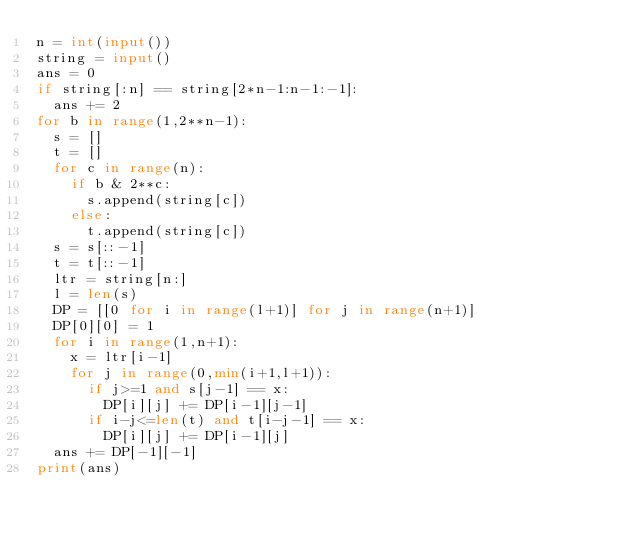<code> <loc_0><loc_0><loc_500><loc_500><_Python_>n = int(input())
string = input()
ans = 0
if string[:n] == string[2*n-1:n-1:-1]:
  ans += 2
for b in range(1,2**n-1):
  s = []
  t = []
  for c in range(n):
    if b & 2**c:
      s.append(string[c])
    else:
      t.append(string[c])
  s = s[::-1]
  t = t[::-1]
  ltr = string[n:]
  l = len(s)
  DP = [[0 for i in range(l+1)] for j in range(n+1)]
  DP[0][0] = 1
  for i in range(1,n+1):
    x = ltr[i-1]
    for j in range(0,min(i+1,l+1)):
      if j>=1 and s[j-1] == x:
        DP[i][j] += DP[i-1][j-1]
      if i-j<=len(t) and t[i-j-1] == x:
        DP[i][j] += DP[i-1][j]
  ans += DP[-1][-1]
print(ans)
</code> 